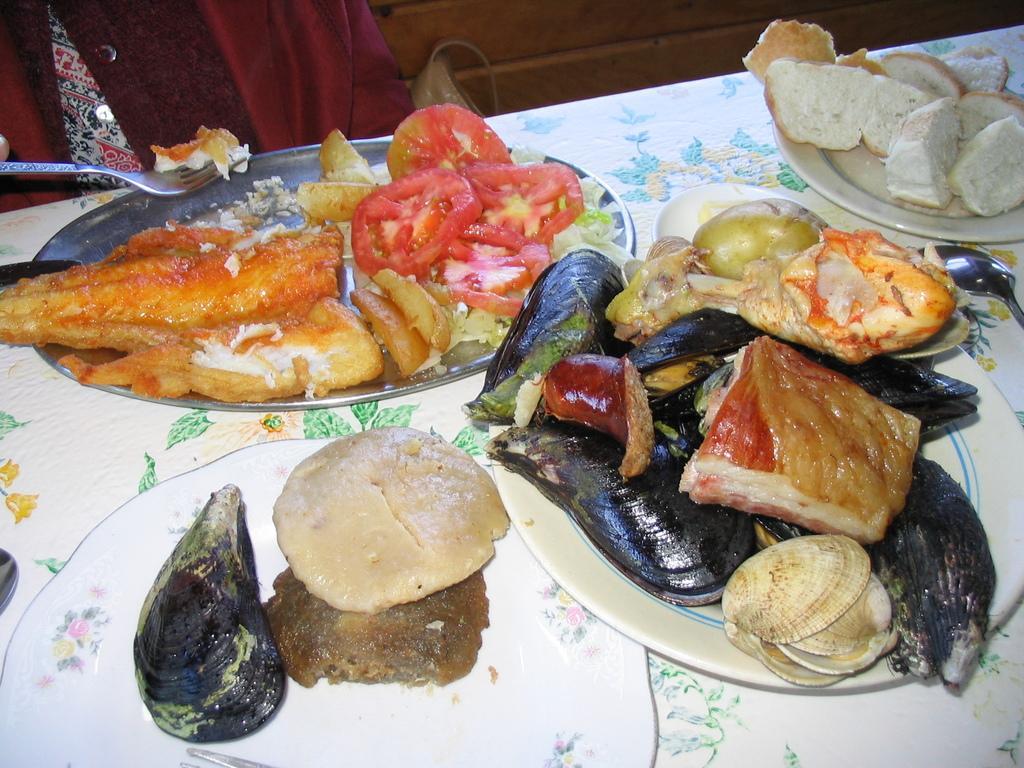Please provide a concise description of this image. The picture consists of a table covered with a cloth, on the table there are plates, platter and various food items. On the left we can see a person holding fork. 